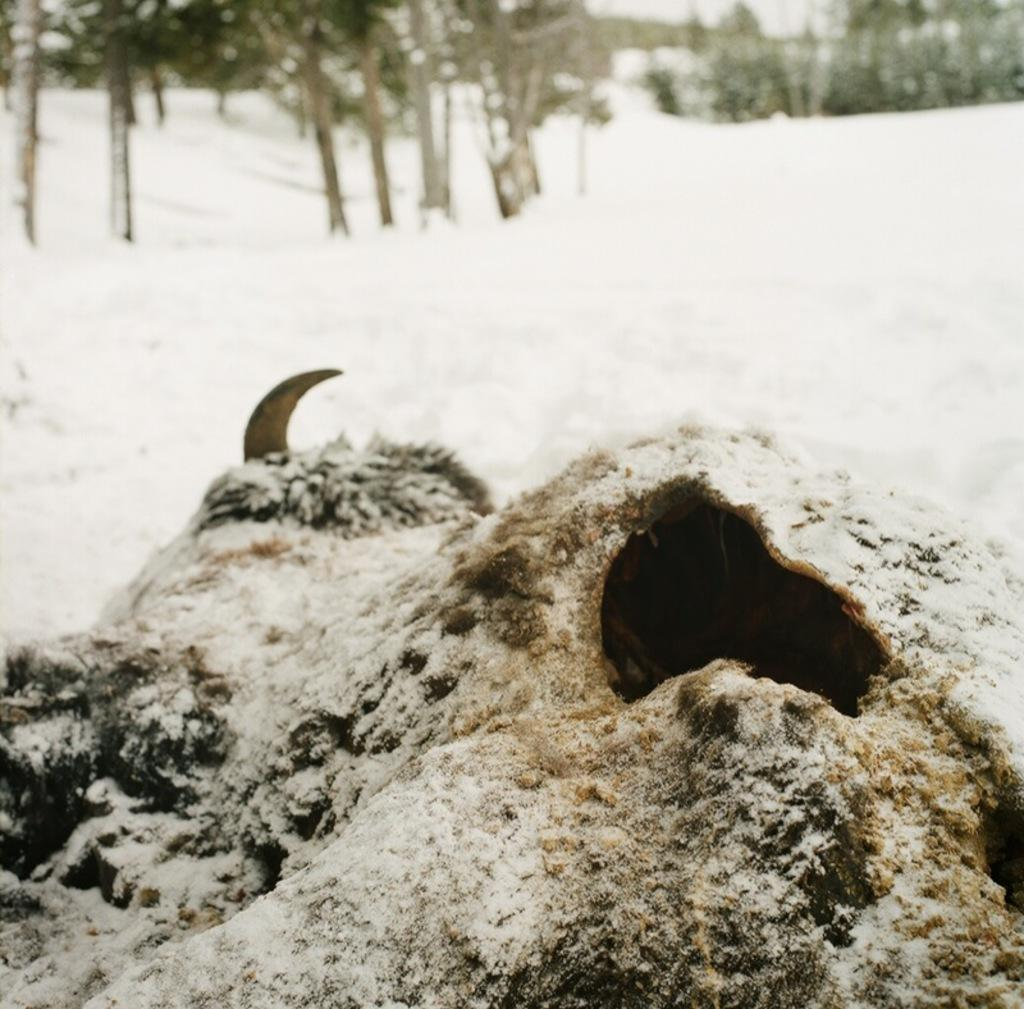What is the main subject in the front portion of the image? There is a decomposed animal in the front portion of the image. What can be seen in the background of the image? There is snow and trees in the background of the image. What type of squirrel can be seen supporting the door in the image? There is no squirrel or door present in the image. 